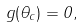<formula> <loc_0><loc_0><loc_500><loc_500>g ( \theta _ { c } ) = 0 ,</formula> 